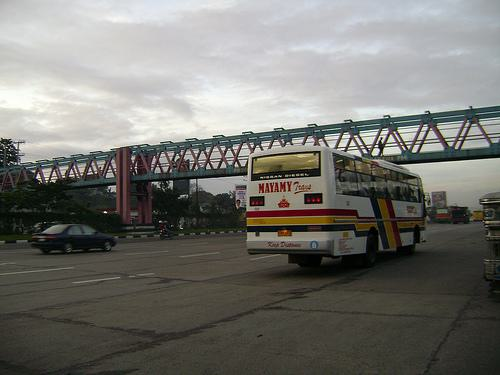What time of day does it appear to be in the image? Given the lighting and shadows, it seems to be either early morning or late afternoon. 